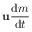<formula> <loc_0><loc_0><loc_500><loc_500>u { \frac { d m } { d t } }</formula> 